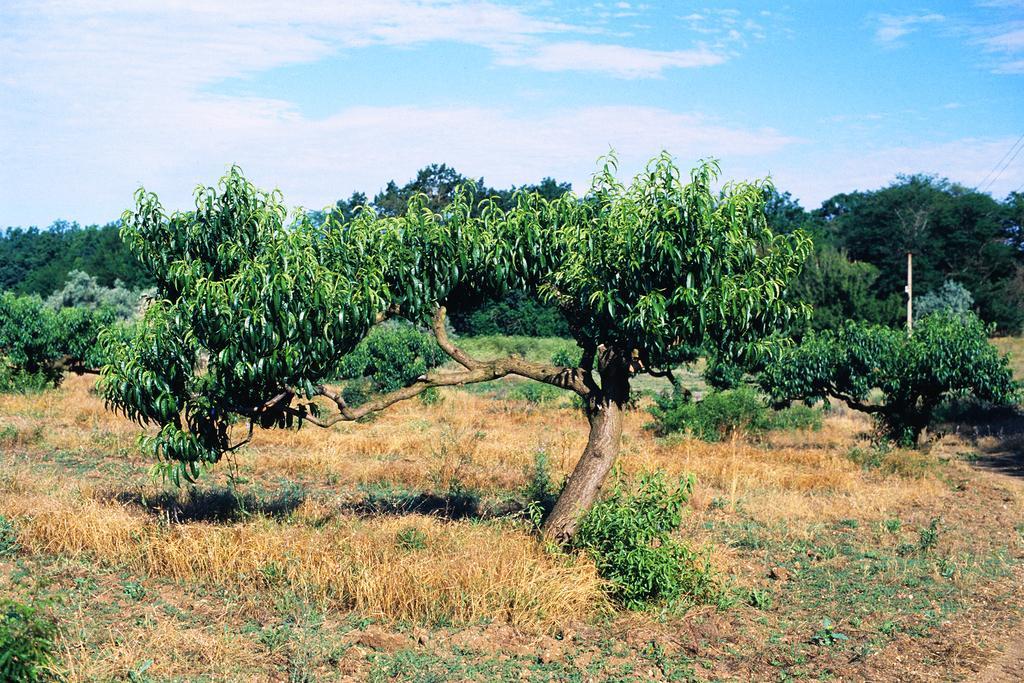How would you summarize this image in a sentence or two? In this image, we can see some trees. There is a grass and some plants on the ground. There is a sky at the top of the image. 